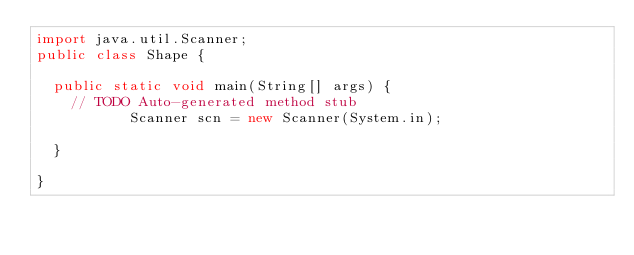Convert code to text. <code><loc_0><loc_0><loc_500><loc_500><_Java_>import java.util.Scanner;
public class Shape {

	public static void main(String[] args) {
		// TODO Auto-generated method stub
           Scanner scn = new Scanner(System.in);
           
	}

}
</code> 